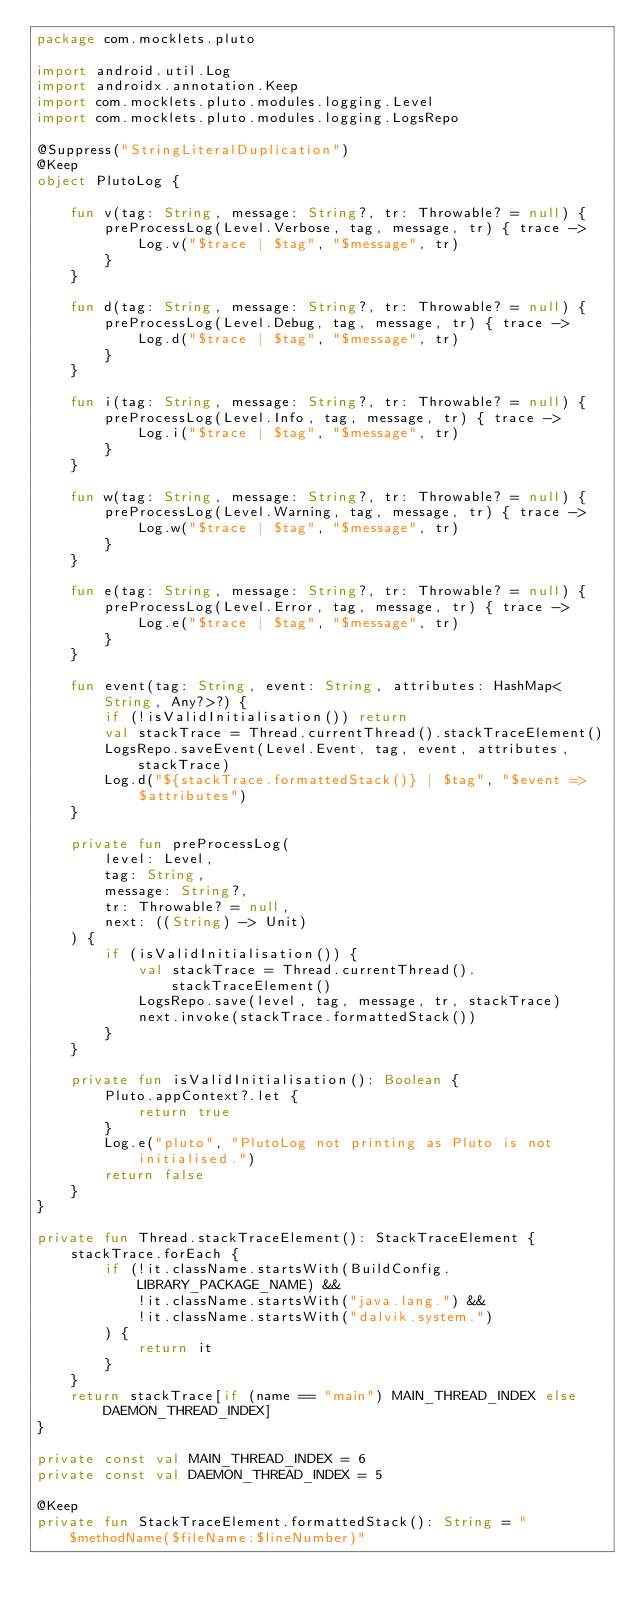<code> <loc_0><loc_0><loc_500><loc_500><_Kotlin_>package com.mocklets.pluto

import android.util.Log
import androidx.annotation.Keep
import com.mocklets.pluto.modules.logging.Level
import com.mocklets.pluto.modules.logging.LogsRepo

@Suppress("StringLiteralDuplication")
@Keep
object PlutoLog {

    fun v(tag: String, message: String?, tr: Throwable? = null) {
        preProcessLog(Level.Verbose, tag, message, tr) { trace ->
            Log.v("$trace | $tag", "$message", tr)
        }
    }

    fun d(tag: String, message: String?, tr: Throwable? = null) {
        preProcessLog(Level.Debug, tag, message, tr) { trace ->
            Log.d("$trace | $tag", "$message", tr)
        }
    }

    fun i(tag: String, message: String?, tr: Throwable? = null) {
        preProcessLog(Level.Info, tag, message, tr) { trace ->
            Log.i("$trace | $tag", "$message", tr)
        }
    }

    fun w(tag: String, message: String?, tr: Throwable? = null) {
        preProcessLog(Level.Warning, tag, message, tr) { trace ->
            Log.w("$trace | $tag", "$message", tr)
        }
    }

    fun e(tag: String, message: String?, tr: Throwable? = null) {
        preProcessLog(Level.Error, tag, message, tr) { trace ->
            Log.e("$trace | $tag", "$message", tr)
        }
    }

    fun event(tag: String, event: String, attributes: HashMap<String, Any?>?) {
        if (!isValidInitialisation()) return
        val stackTrace = Thread.currentThread().stackTraceElement()
        LogsRepo.saveEvent(Level.Event, tag, event, attributes, stackTrace)
        Log.d("${stackTrace.formattedStack()} | $tag", "$event => $attributes")
    }

    private fun preProcessLog(
        level: Level,
        tag: String,
        message: String?,
        tr: Throwable? = null,
        next: ((String) -> Unit)
    ) {
        if (isValidInitialisation()) {
            val stackTrace = Thread.currentThread().stackTraceElement()
            LogsRepo.save(level, tag, message, tr, stackTrace)
            next.invoke(stackTrace.formattedStack())
        }
    }

    private fun isValidInitialisation(): Boolean {
        Pluto.appContext?.let {
            return true
        }
        Log.e("pluto", "PlutoLog not printing as Pluto is not initialised.")
        return false
    }
}

private fun Thread.stackTraceElement(): StackTraceElement {
    stackTrace.forEach {
        if (!it.className.startsWith(BuildConfig.LIBRARY_PACKAGE_NAME) &&
            !it.className.startsWith("java.lang.") &&
            !it.className.startsWith("dalvik.system.")
        ) {
            return it
        }
    }
    return stackTrace[if (name == "main") MAIN_THREAD_INDEX else DAEMON_THREAD_INDEX]
}

private const val MAIN_THREAD_INDEX = 6
private const val DAEMON_THREAD_INDEX = 5

@Keep
private fun StackTraceElement.formattedStack(): String = "$methodName($fileName:$lineNumber)"
</code> 